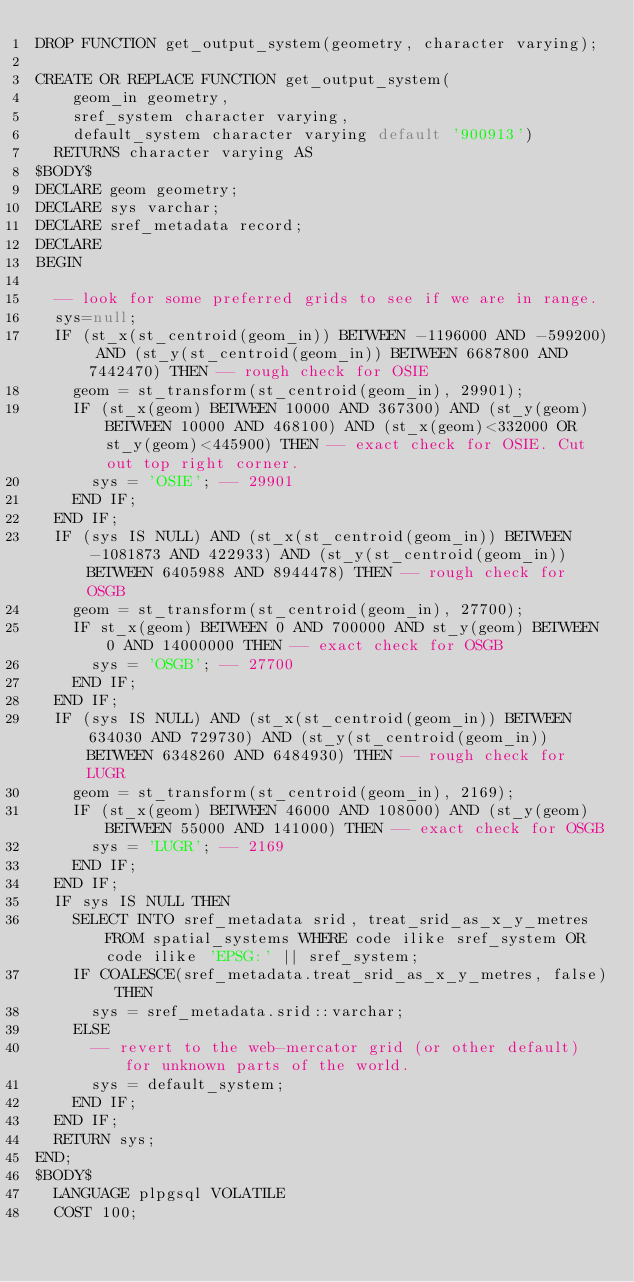<code> <loc_0><loc_0><loc_500><loc_500><_SQL_>DROP FUNCTION get_output_system(geometry, character varying);

CREATE OR REPLACE FUNCTION get_output_system(
    geom_in geometry,
    sref_system character varying,
    default_system character varying default '900913')
  RETURNS character varying AS
$BODY$
DECLARE geom geometry;
DECLARE sys varchar;
DECLARE sref_metadata record;
DECLARE
BEGIN

  -- look for some preferred grids to see if we are in range.
  sys=null;
  IF (st_x(st_centroid(geom_in)) BETWEEN -1196000 AND -599200) AND (st_y(st_centroid(geom_in)) BETWEEN 6687800 AND 7442470) THEN -- rough check for OSIE
    geom = st_transform(st_centroid(geom_in), 29901);
    IF (st_x(geom) BETWEEN 10000 AND 367300) AND (st_y(geom) BETWEEN 10000 AND 468100) AND (st_x(geom)<332000 OR st_y(geom)<445900) THEN -- exact check for OSIE. Cut out top right corner.
      sys = 'OSIE'; -- 29901
    END IF;
  END IF;
  IF (sys IS NULL) AND (st_x(st_centroid(geom_in)) BETWEEN -1081873 AND 422933) AND (st_y(st_centroid(geom_in)) BETWEEN 6405988 AND 8944478) THEN -- rough check for OSGB
    geom = st_transform(st_centroid(geom_in), 27700);
    IF st_x(geom) BETWEEN 0 AND 700000 AND st_y(geom) BETWEEN 0 AND 14000000 THEN -- exact check for OSGB
      sys = 'OSGB'; -- 27700
    END IF;
  END IF;
  IF (sys IS NULL) AND (st_x(st_centroid(geom_in)) BETWEEN 634030 AND 729730) AND (st_y(st_centroid(geom_in)) BETWEEN 6348260 AND 6484930) THEN -- rough check for LUGR
    geom = st_transform(st_centroid(geom_in), 2169);
    IF (st_x(geom) BETWEEN 46000 AND 108000) AND (st_y(geom) BETWEEN 55000 AND 141000) THEN -- exact check for OSGB
      sys = 'LUGR'; -- 2169
    END IF;
  END IF;
  IF sys IS NULL THEN
    SELECT INTO sref_metadata srid, treat_srid_as_x_y_metres FROM spatial_systems WHERE code ilike sref_system OR code ilike 'EPSG:' || sref_system;
    IF COALESCE(sref_metadata.treat_srid_as_x_y_metres, false) THEN
      sys = sref_metadata.srid::varchar;
    ELSE
      -- revert to the web-mercator grid (or other default) for unknown parts of the world.
      sys = default_system;
    END IF;
  END IF;
  RETURN sys;
END;
$BODY$
  LANGUAGE plpgsql VOLATILE
  COST 100;
</code> 